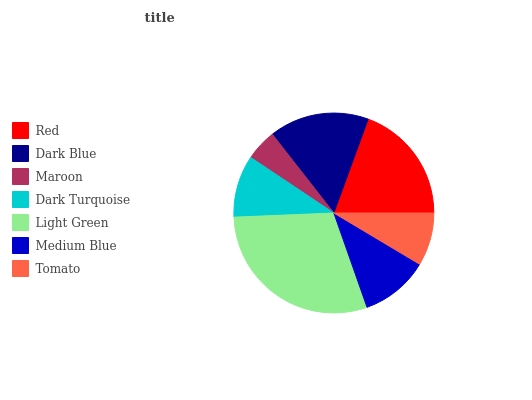Is Maroon the minimum?
Answer yes or no. Yes. Is Light Green the maximum?
Answer yes or no. Yes. Is Dark Blue the minimum?
Answer yes or no. No. Is Dark Blue the maximum?
Answer yes or no. No. Is Red greater than Dark Blue?
Answer yes or no. Yes. Is Dark Blue less than Red?
Answer yes or no. Yes. Is Dark Blue greater than Red?
Answer yes or no. No. Is Red less than Dark Blue?
Answer yes or no. No. Is Medium Blue the high median?
Answer yes or no. Yes. Is Medium Blue the low median?
Answer yes or no. Yes. Is Red the high median?
Answer yes or no. No. Is Light Green the low median?
Answer yes or no. No. 